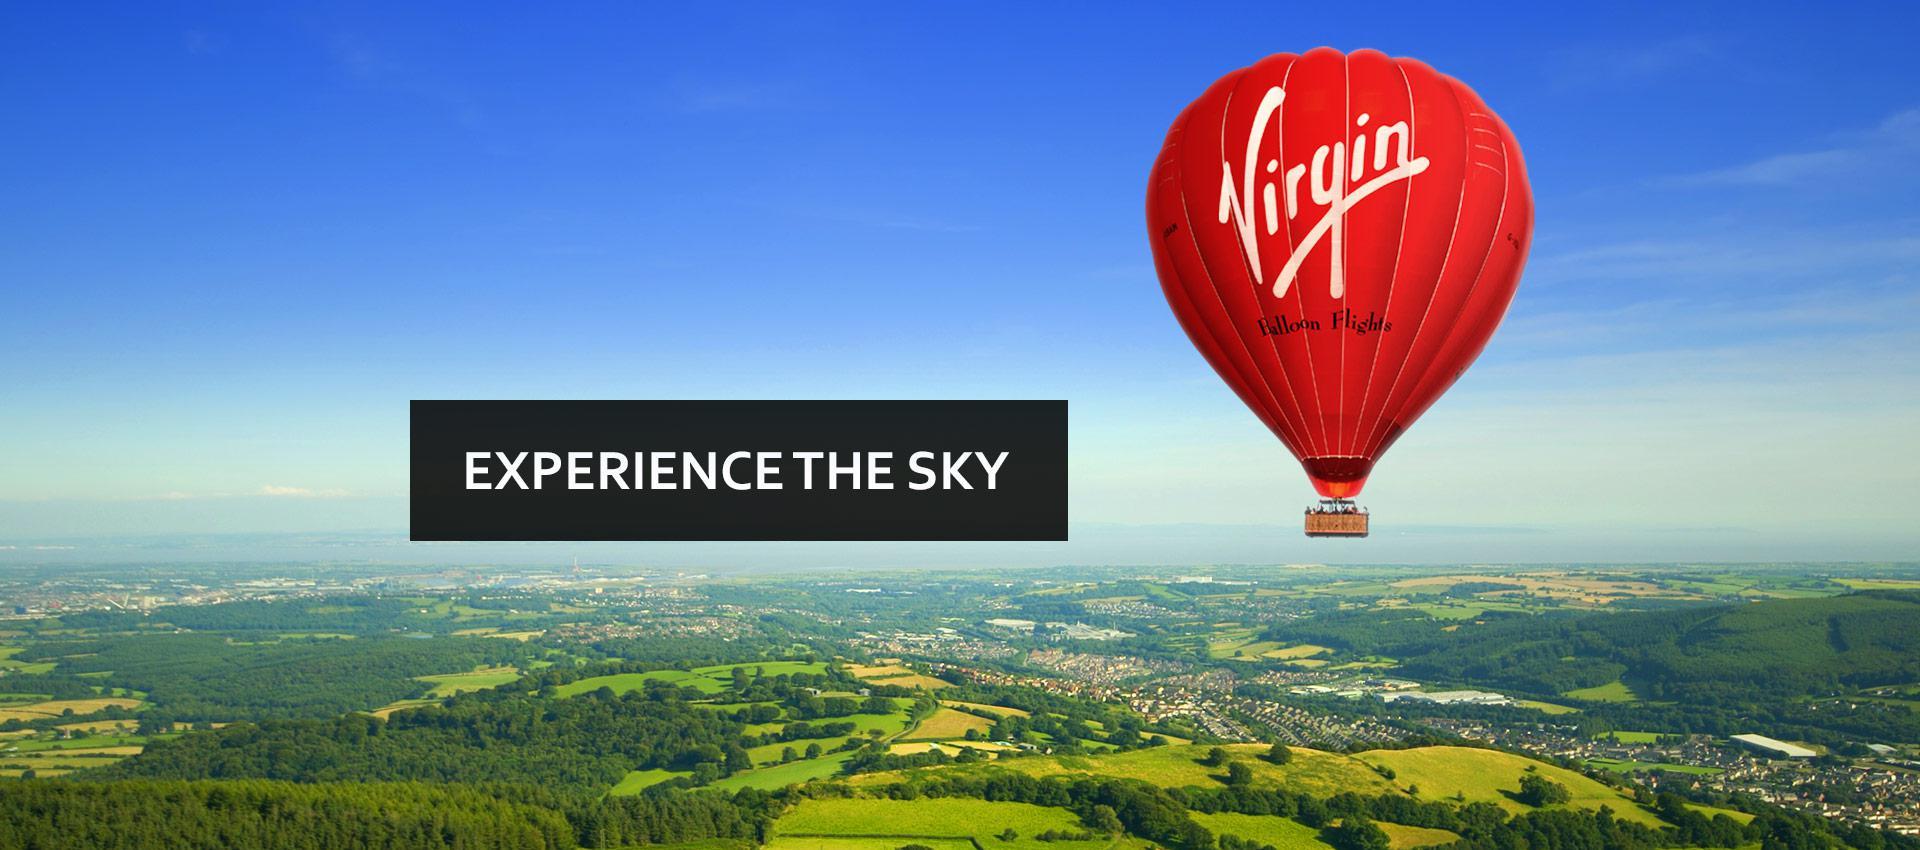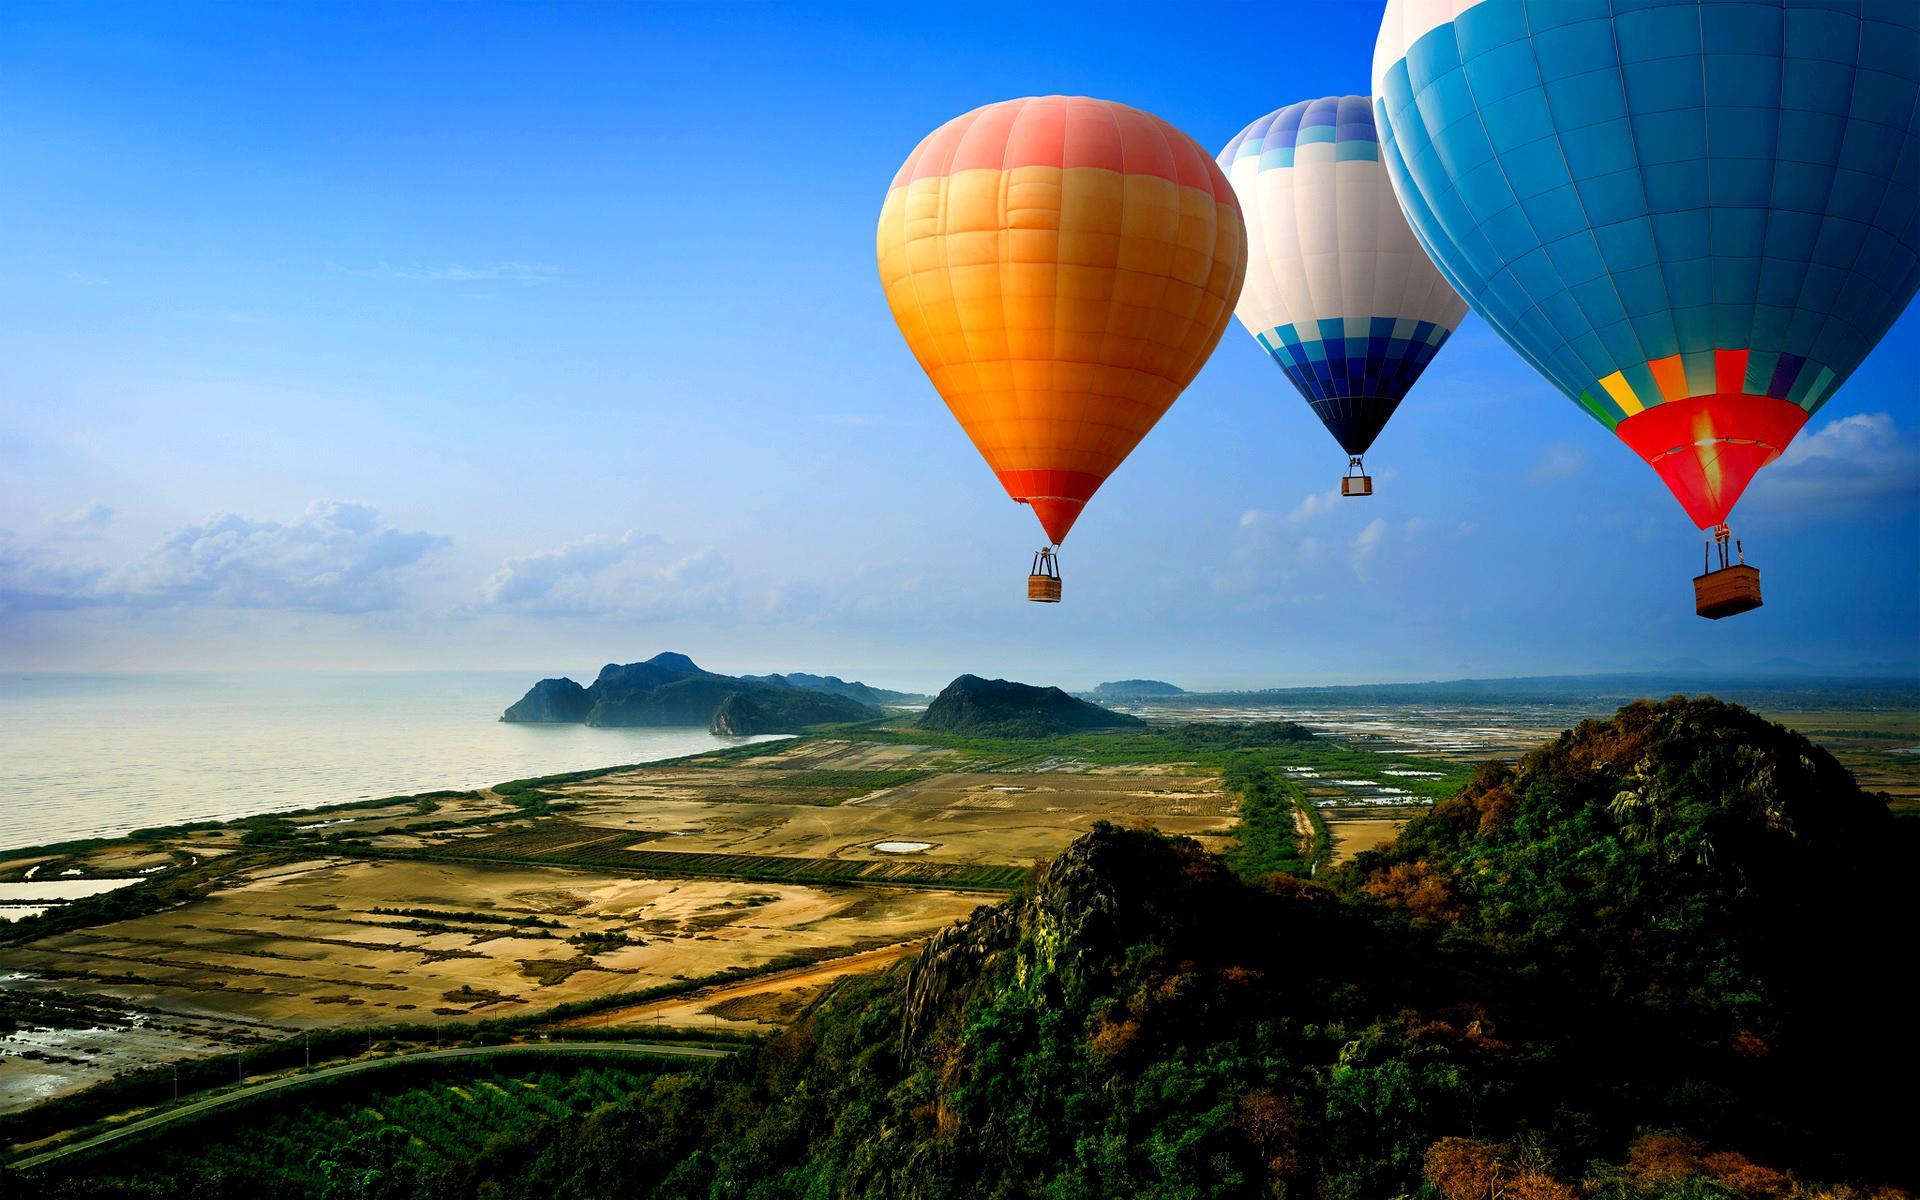The first image is the image on the left, the second image is the image on the right. Analyze the images presented: Is the assertion "All hot air balloons have the same company logo." valid? Answer yes or no. No. The first image is the image on the left, the second image is the image on the right. Analyze the images presented: Is the assertion "There are only two balloons and they are both upright." valid? Answer yes or no. No. 